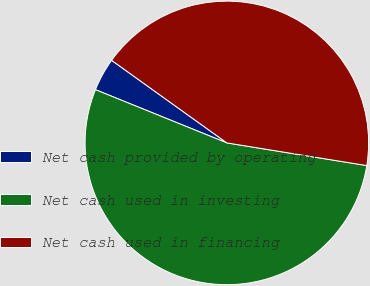Convert chart to OTSL. <chart><loc_0><loc_0><loc_500><loc_500><pie_chart><fcel>Net cash provided by operating<fcel>Net cash used in investing<fcel>Net cash used in financing<nl><fcel>3.77%<fcel>53.57%<fcel>42.66%<nl></chart> 